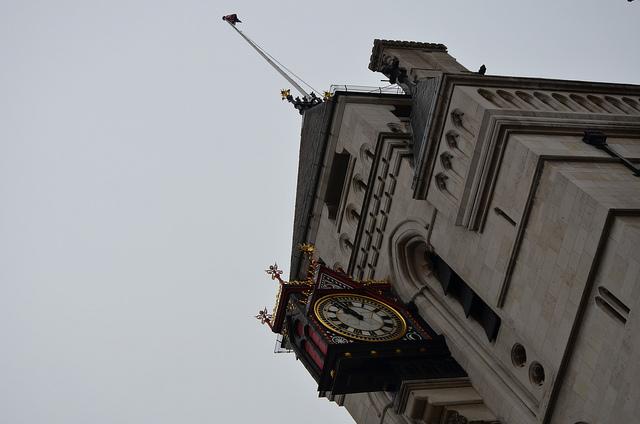What color is the trim around the clock face?
Short answer required. Gold. Where is the clock?
Concise answer only. On building. What time is it?
Keep it brief. 11:58. 